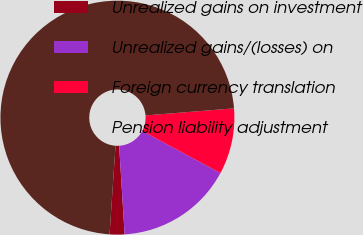<chart> <loc_0><loc_0><loc_500><loc_500><pie_chart><fcel>Unrealized gains on investment<fcel>Unrealized gains/(losses) on<fcel>Foreign currency translation<fcel>Pension liability adjustment<nl><fcel>2.05%<fcel>16.17%<fcel>9.11%<fcel>72.66%<nl></chart> 